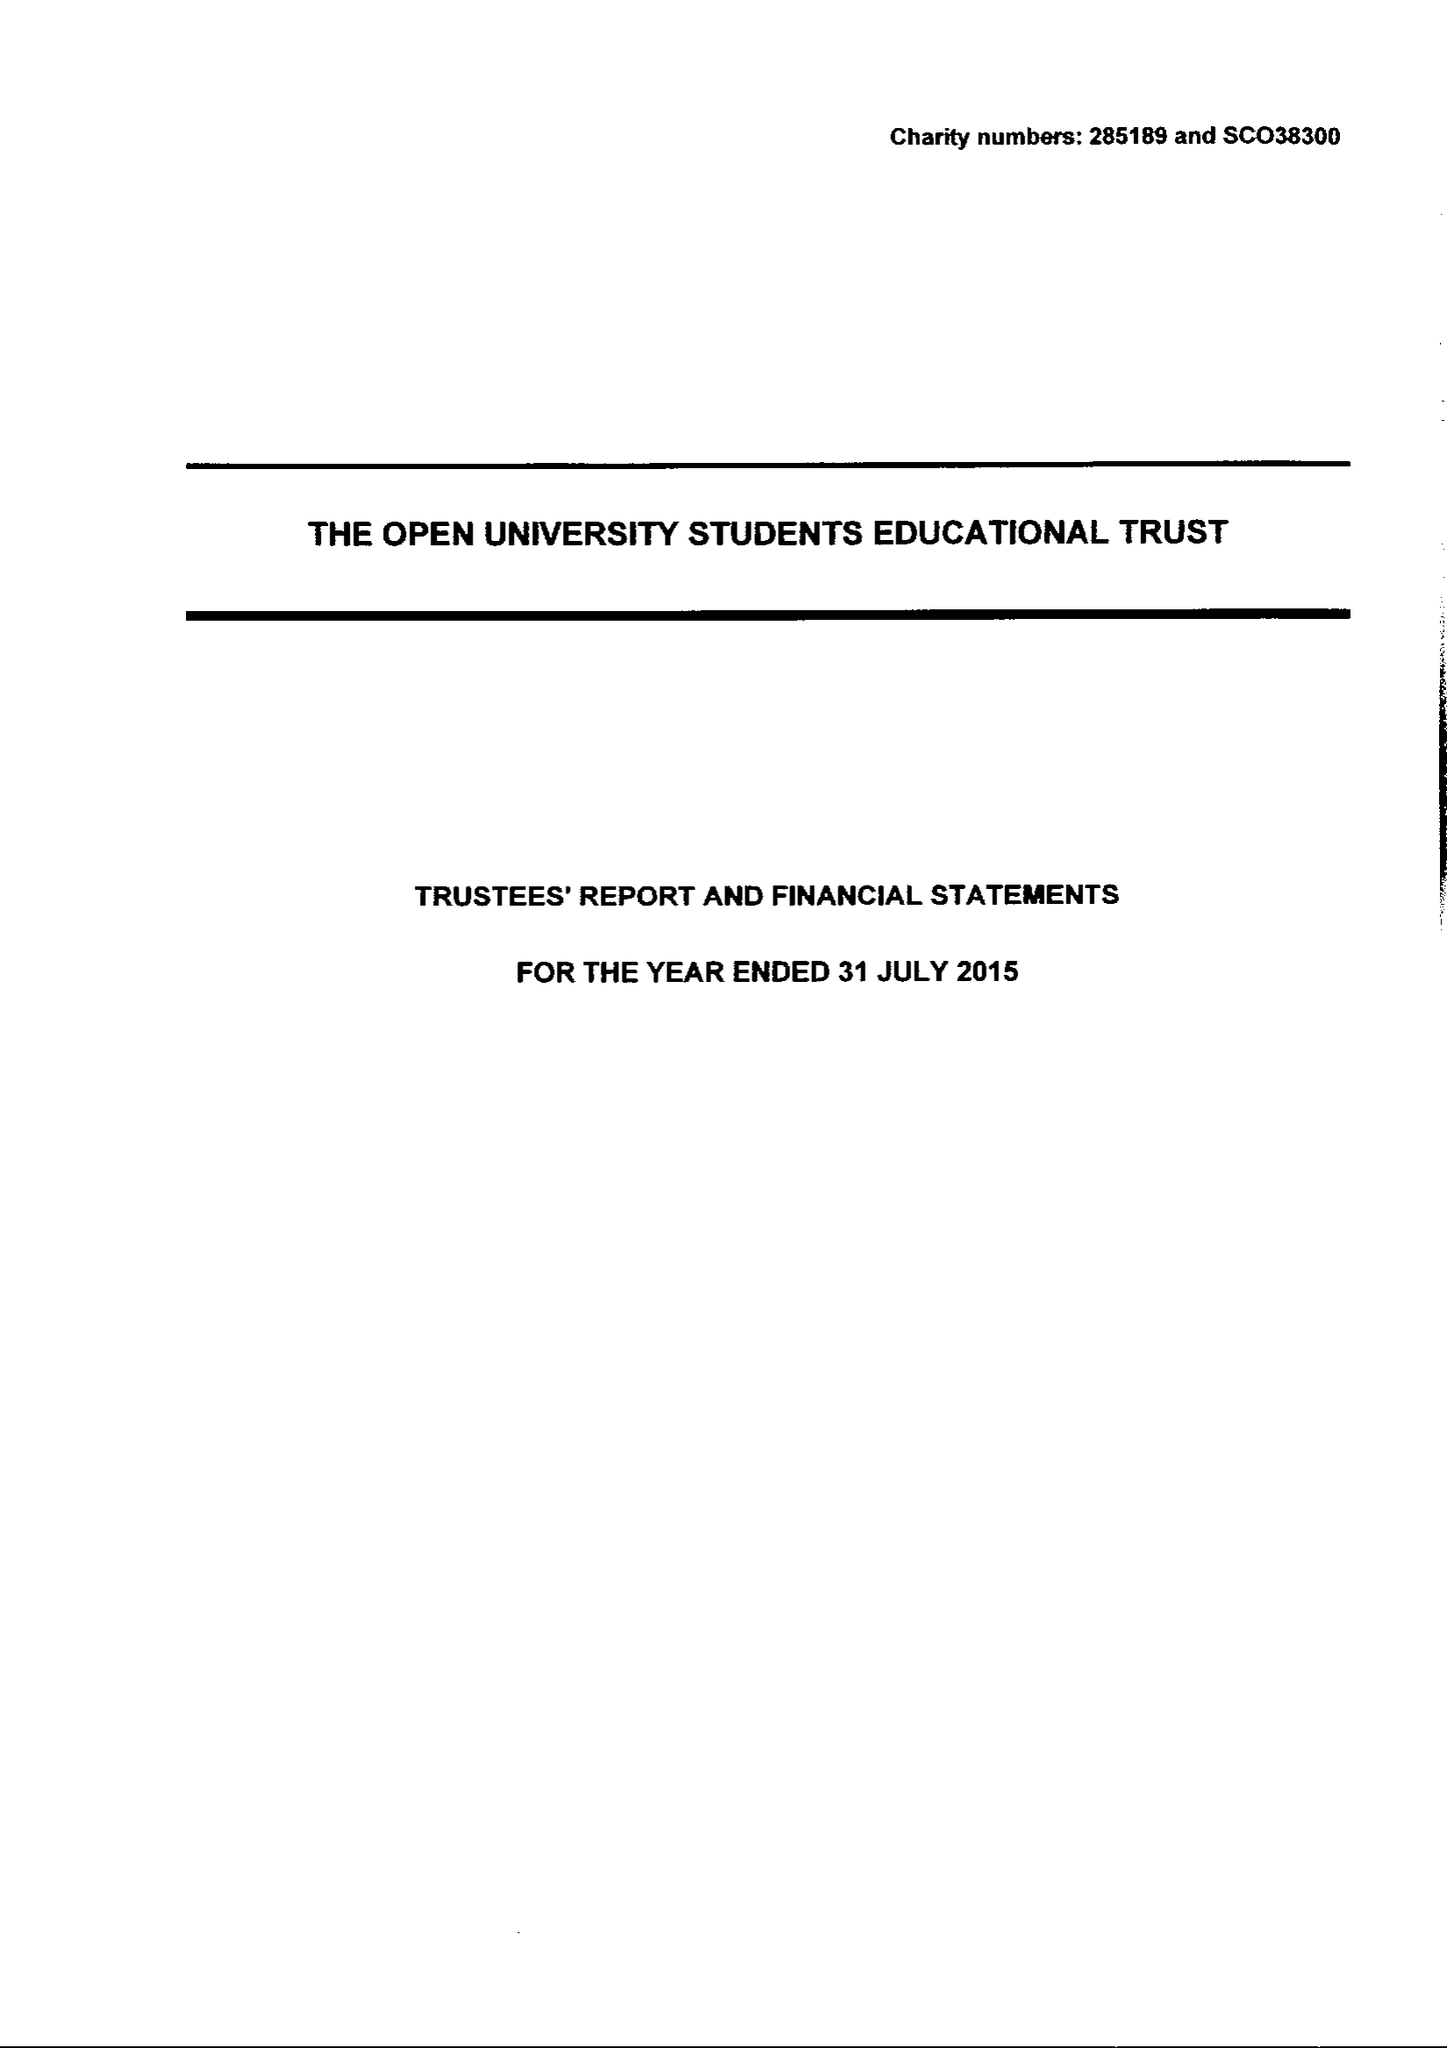What is the value for the charity_number?
Answer the question using a single word or phrase. 285189 